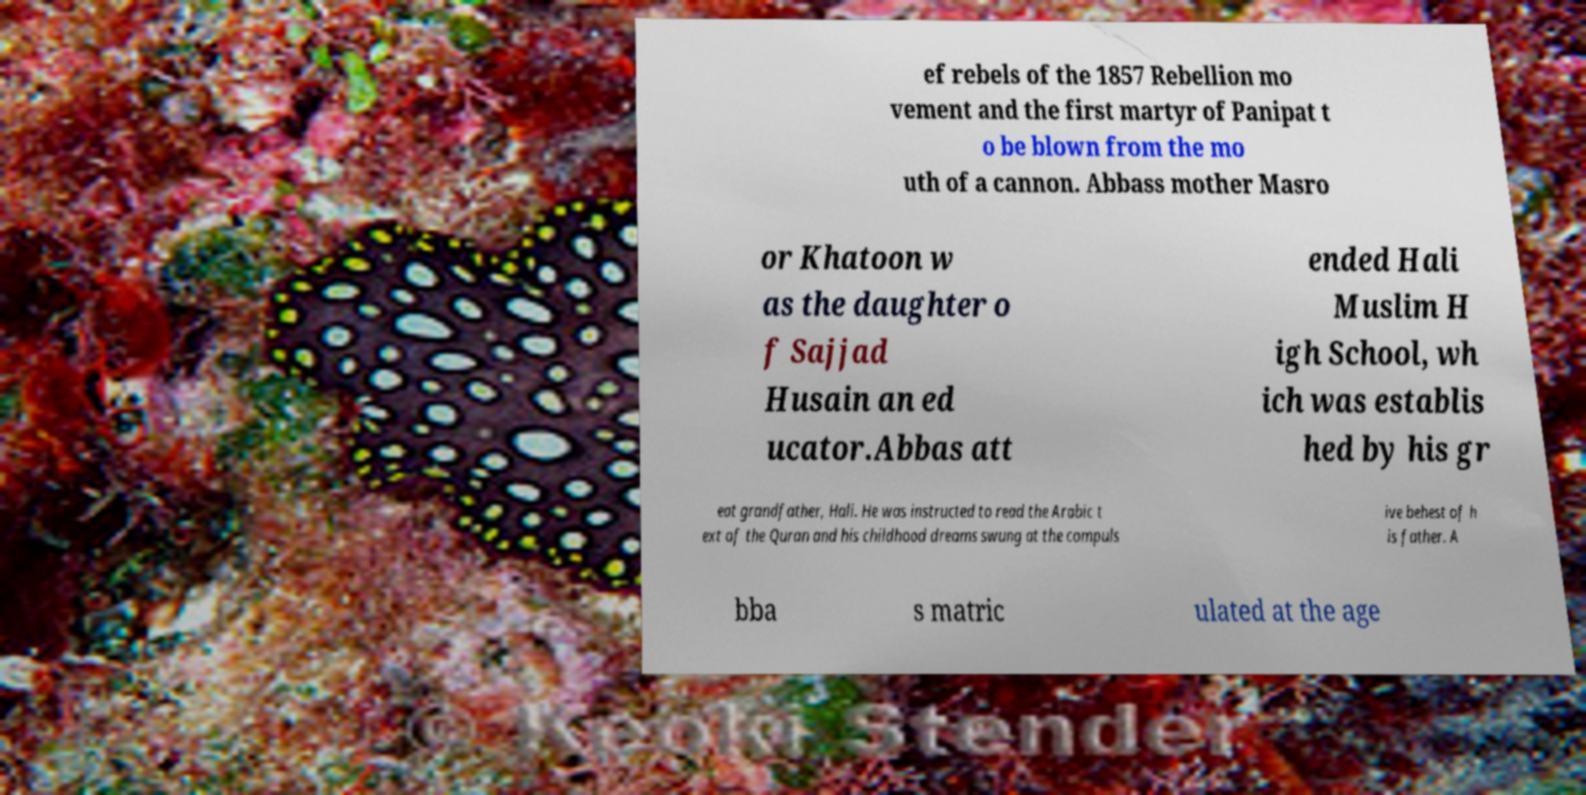What messages or text are displayed in this image? I need them in a readable, typed format. ef rebels of the 1857 Rebellion mo vement and the first martyr of Panipat t o be blown from the mo uth of a cannon. Abbass mother Masro or Khatoon w as the daughter o f Sajjad Husain an ed ucator.Abbas att ended Hali Muslim H igh School, wh ich was establis hed by his gr eat grandfather, Hali. He was instructed to read the Arabic t ext of the Quran and his childhood dreams swung at the compuls ive behest of h is father. A bba s matric ulated at the age 